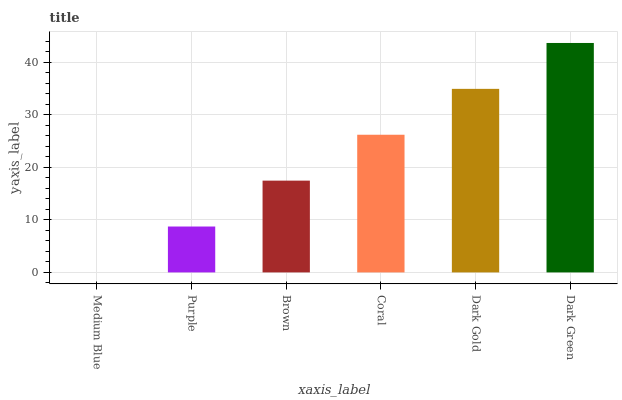Is Medium Blue the minimum?
Answer yes or no. Yes. Is Dark Green the maximum?
Answer yes or no. Yes. Is Purple the minimum?
Answer yes or no. No. Is Purple the maximum?
Answer yes or no. No. Is Purple greater than Medium Blue?
Answer yes or no. Yes. Is Medium Blue less than Purple?
Answer yes or no. Yes. Is Medium Blue greater than Purple?
Answer yes or no. No. Is Purple less than Medium Blue?
Answer yes or no. No. Is Coral the high median?
Answer yes or no. Yes. Is Brown the low median?
Answer yes or no. Yes. Is Medium Blue the high median?
Answer yes or no. No. Is Coral the low median?
Answer yes or no. No. 